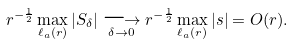Convert formula to latex. <formula><loc_0><loc_0><loc_500><loc_500>r ^ { - \frac { 1 } { 2 } } \max _ { \ell _ { a } ( r ) } | S _ { \delta } | \underset { \delta \to 0 } { \longrightarrow } r ^ { - \frac { 1 } { 2 } } \max _ { \ell _ { a } ( r ) } | s | = O ( r ) .</formula> 